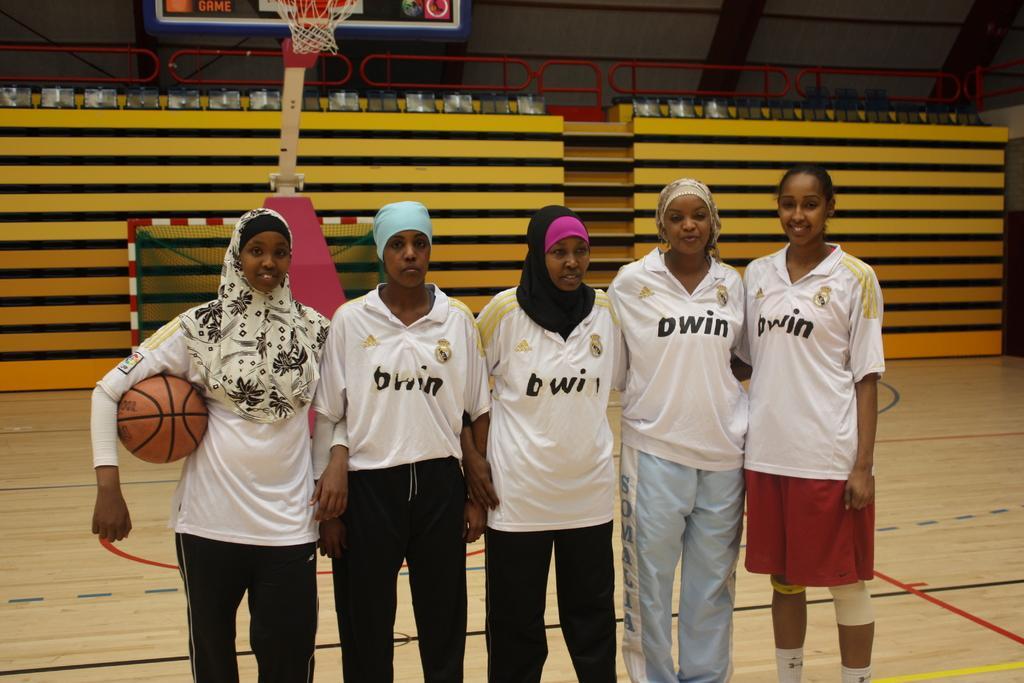Can you describe this image briefly? In this image women are standing on the playground having a net. Left side there is a woman having a ball. Background there is a wall. There is a basket attached to the board which is attached to a pole. 